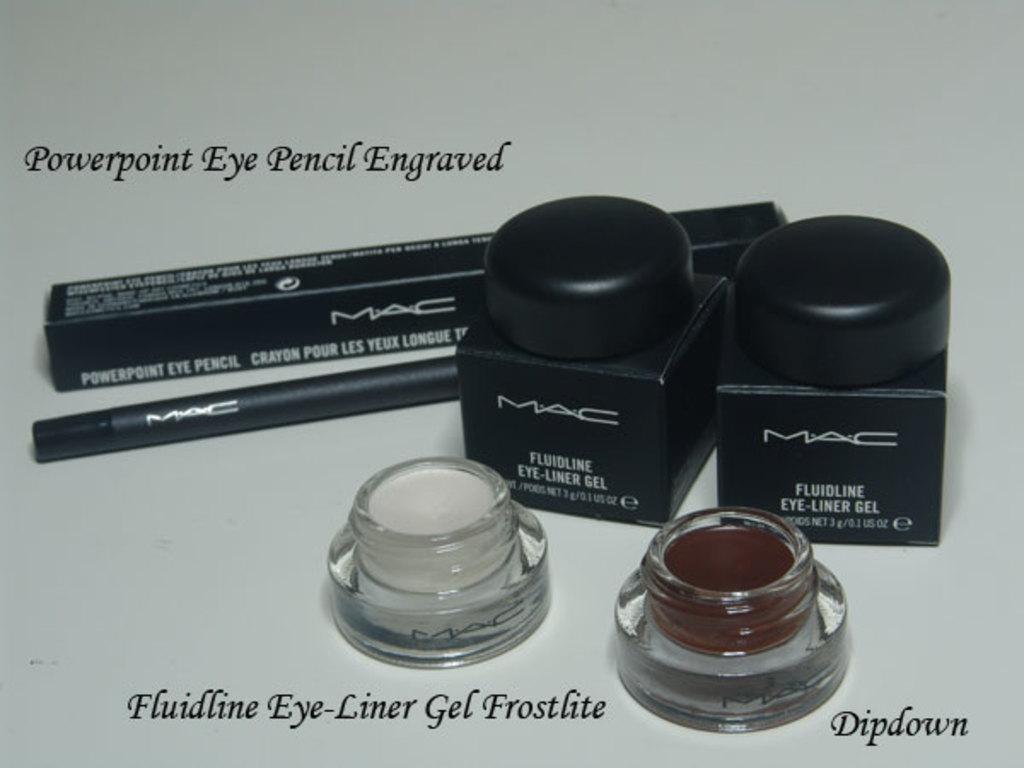<image>
Present a compact description of the photo's key features. Mac makeup is shown with some products open and some closed 